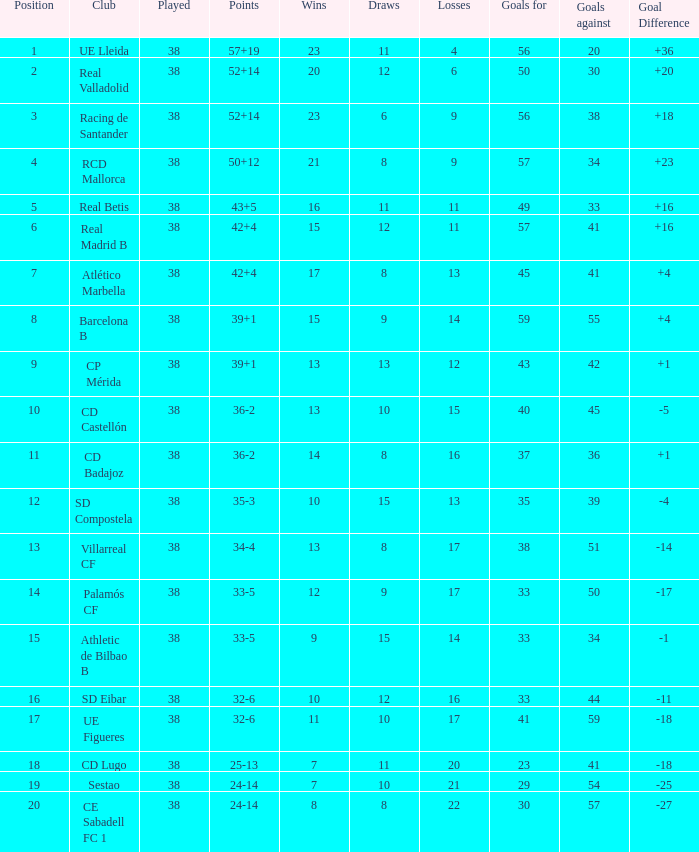What is the largest number attained with a goal difference under -27? None. 